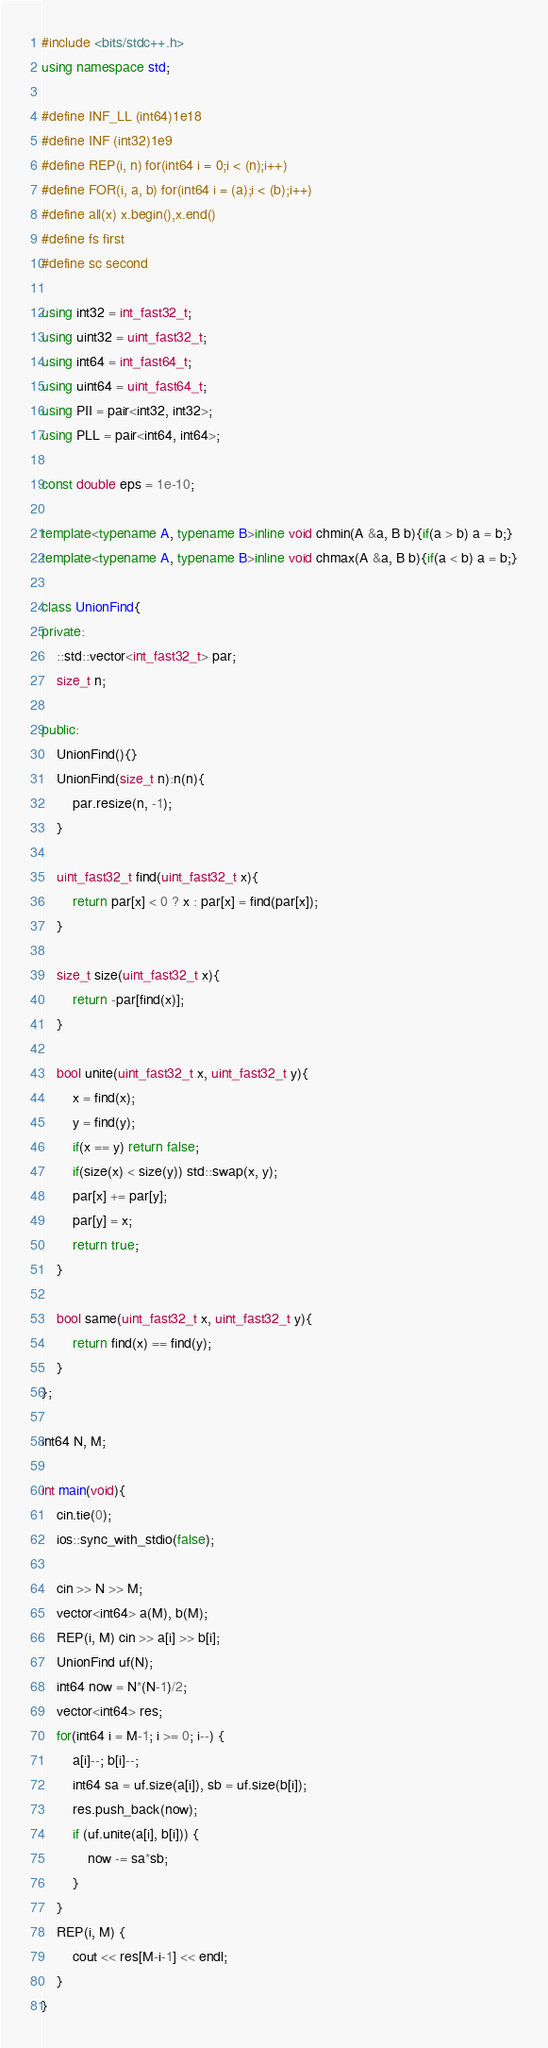<code> <loc_0><loc_0><loc_500><loc_500><_C++_>#include <bits/stdc++.h>
using namespace std;

#define INF_LL (int64)1e18
#define INF (int32)1e9
#define REP(i, n) for(int64 i = 0;i < (n);i++)
#define FOR(i, a, b) for(int64 i = (a);i < (b);i++)
#define all(x) x.begin(),x.end()
#define fs first
#define sc second

using int32 = int_fast32_t;
using uint32 = uint_fast32_t;
using int64 = int_fast64_t;
using uint64 = uint_fast64_t;
using PII = pair<int32, int32>;
using PLL = pair<int64, int64>;

const double eps = 1e-10;

template<typename A, typename B>inline void chmin(A &a, B b){if(a > b) a = b;}
template<typename A, typename B>inline void chmax(A &a, B b){if(a < b) a = b;}

class UnionFind{
private:
	::std::vector<int_fast32_t> par;
	size_t n;

public:
	UnionFind(){}
	UnionFind(size_t n):n(n){
		par.resize(n, -1);
	}

	uint_fast32_t find(uint_fast32_t x){
		return par[x] < 0 ? x : par[x] = find(par[x]);
	}

	size_t size(uint_fast32_t x){
		return -par[find(x)];
	}

	bool unite(uint_fast32_t x, uint_fast32_t y){
		x = find(x);
		y = find(y);
		if(x == y) return false;
		if(size(x) < size(y)) std::swap(x, y);
		par[x] += par[y];
		par[y] = x;
		return true;
	}

	bool same(uint_fast32_t x, uint_fast32_t y){
		return find(x) == find(y);
	}
};

int64 N, M;

int main(void){
	cin.tie(0);
	ios::sync_with_stdio(false);

	cin >> N >> M;
	vector<int64> a(M), b(M);
	REP(i, M) cin >> a[i] >> b[i];
	UnionFind uf(N);
	int64 now = N*(N-1)/2;
	vector<int64> res;
	for(int64 i = M-1; i >= 0; i--) {
		a[i]--; b[i]--;
		int64 sa = uf.size(a[i]), sb = uf.size(b[i]);
		res.push_back(now);
		if (uf.unite(a[i], b[i])) {
			now -= sa*sb;
		}
	}
	REP(i, M) {
		cout << res[M-i-1] << endl;
	}
}
</code> 